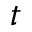Convert formula to latex. <formula><loc_0><loc_0><loc_500><loc_500>t</formula> 